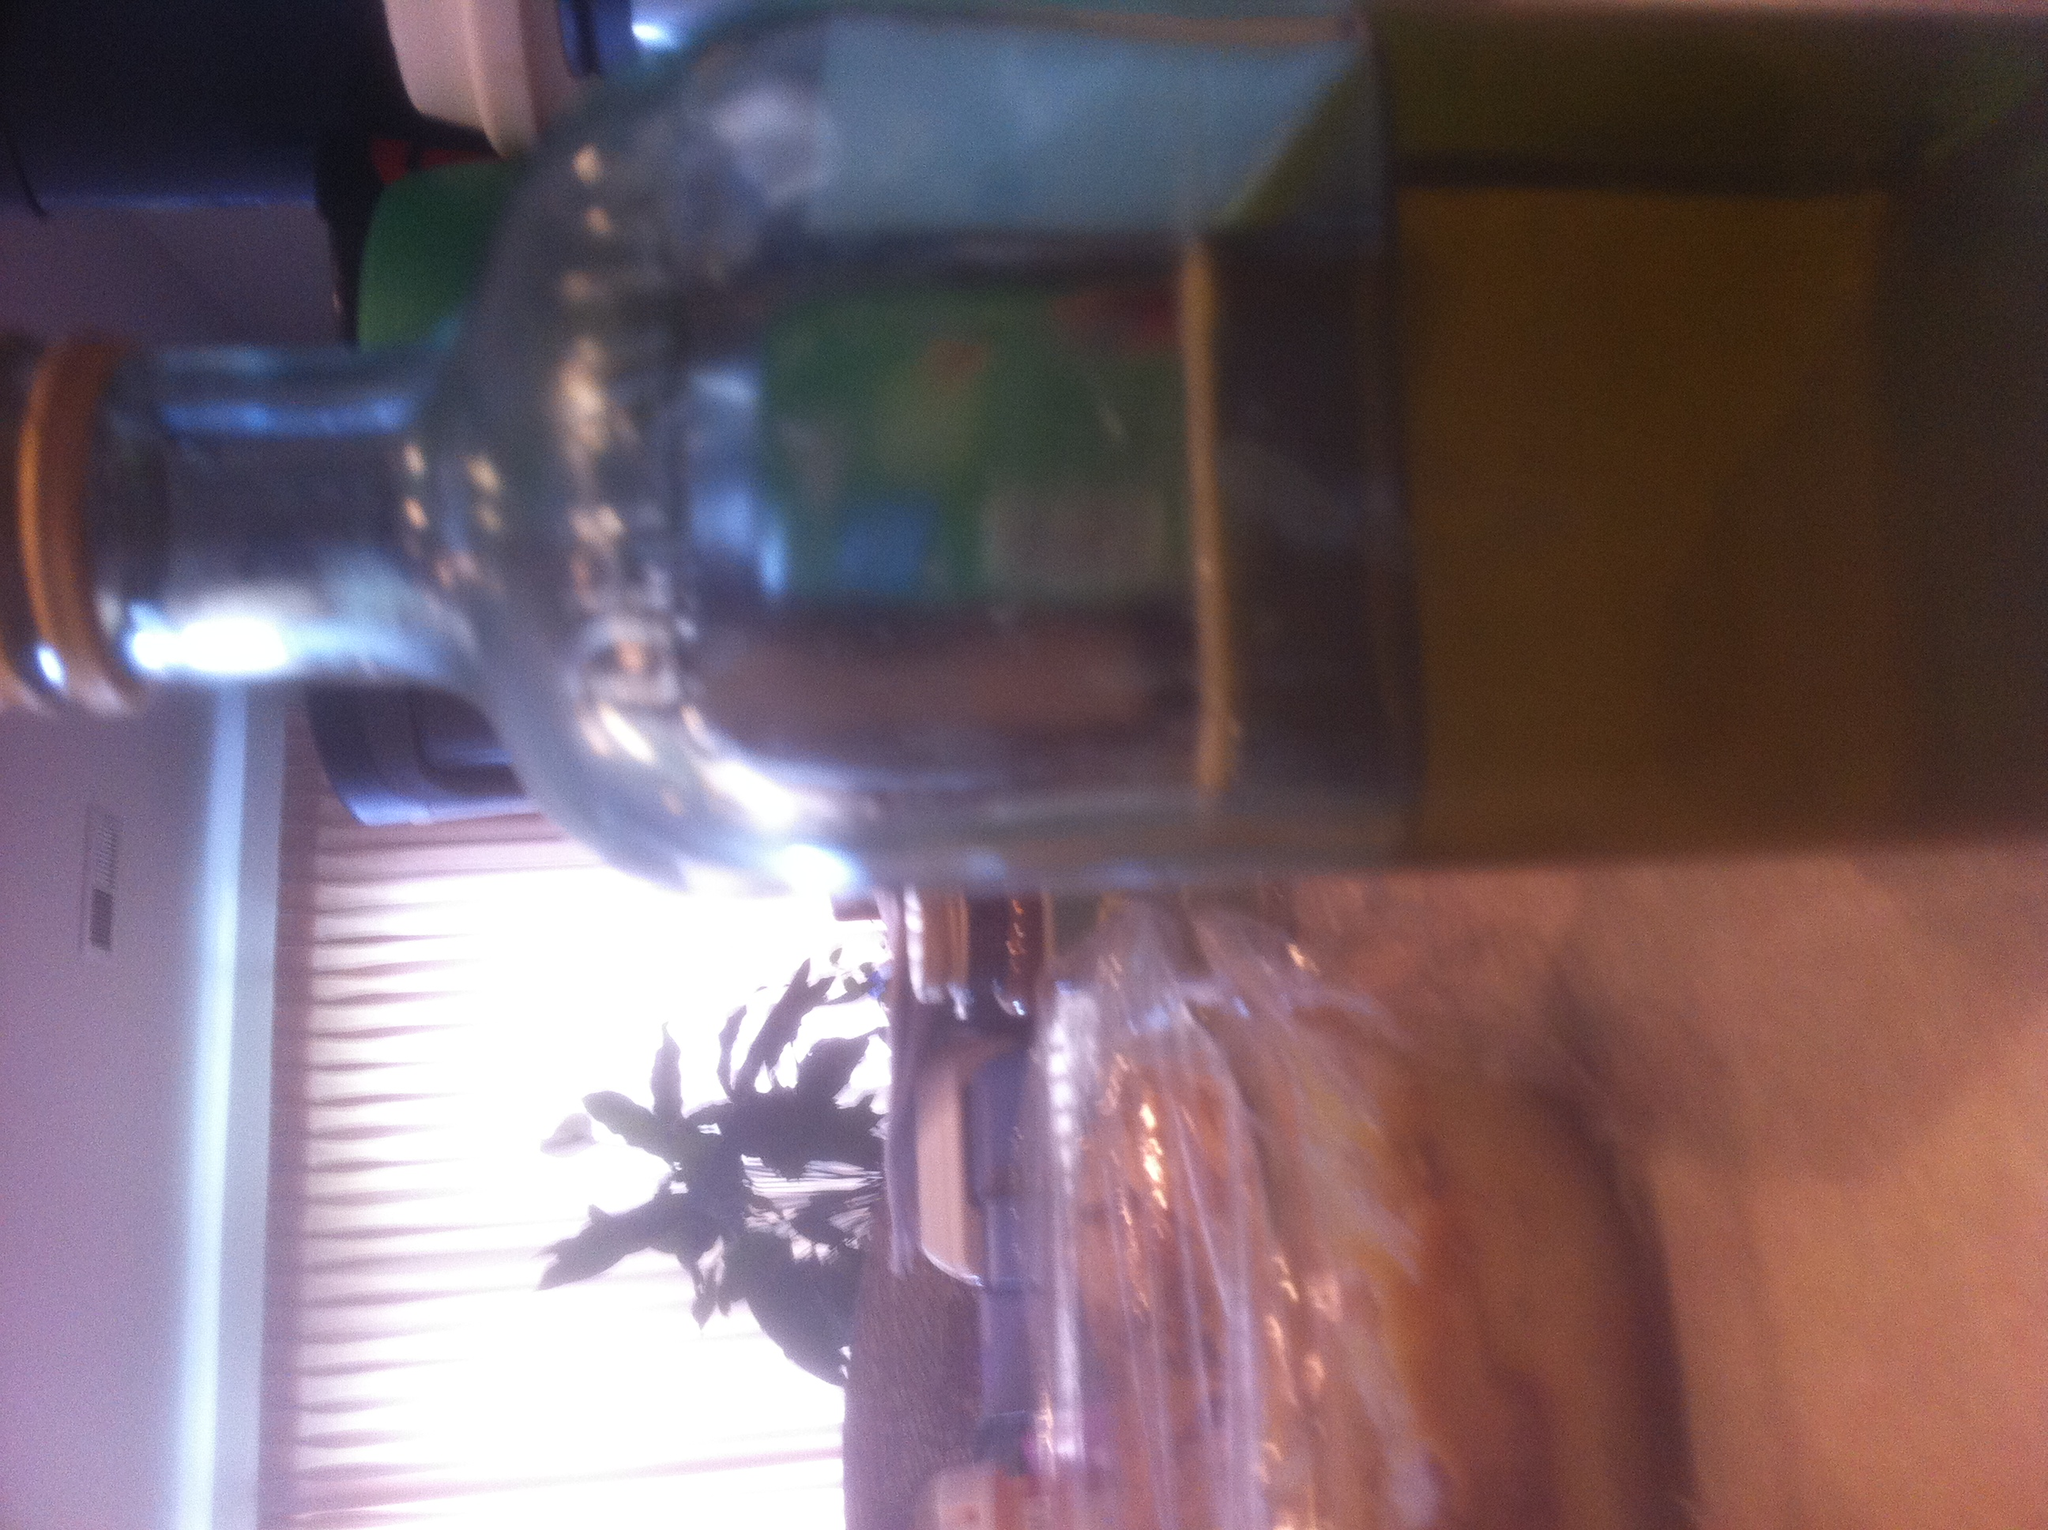What modern kitchen appliance might replace the function of this bottle in a household? A modern kitchen appliance that might replace the function of this bottle could be an automatic oil sprayer. Such devices store cooking oils and have mechanisms to spray precise amounts over food, making them more convenient for cooking and salads. Additionally, specialized dispensers for vinegars and sauces are also available, meant to replace traditional bottles for a more controlled and hygienic handling of liquid ingredients. 